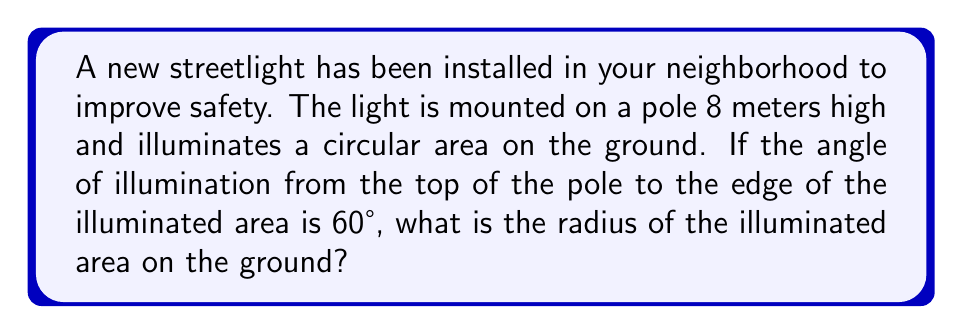Solve this math problem. Let's approach this step-by-step:

1) We can visualize this problem as a right triangle, where:
   - The height of the streetlight is the adjacent side (8 meters)
   - The radius of the illuminated area is the opposite side
   - The angle of illumination is 60°

2) In a right triangle, the tangent of an angle is the ratio of the opposite side to the adjacent side:

   $$\tan \theta = \frac{\text{opposite}}{\text{adjacent}}$$

3) In this case:

   $$\tan 60° = \frac{\text{radius}}{8}$$

4) We know that $\tan 60° = \sqrt{3}$, so we can write:

   $$\sqrt{3} = \frac{\text{radius}}{8}$$

5) To solve for the radius, multiply both sides by 8:

   $$8\sqrt{3} = \text{radius}$$

6) Simplify:

   $$\text{radius} = 8\sqrt{3} \approx 13.86 \text{ meters}$$

[asy]
import geometry;

size(200);

pair A = (0,0), B = (13.86,0), C = (0,8);
draw(A--B--C--A);
draw(rightanglemark(A,B,C,8));

label("8 m", C--A, W);
label("13.86 m", A--B, S);
label("60°", B--C--A, NE);

dot("Ground", A, SW);
dot("Light", C, N);
[/asy]
Answer: $8\sqrt{3}$ meters 